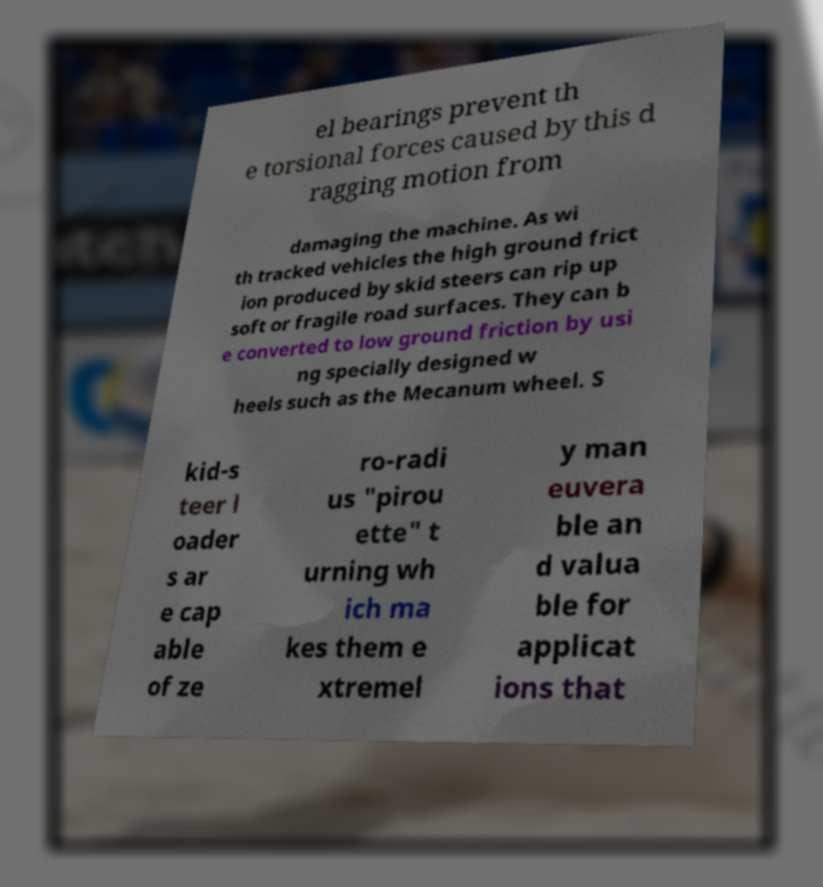For documentation purposes, I need the text within this image transcribed. Could you provide that? el bearings prevent th e torsional forces caused by this d ragging motion from damaging the machine. As wi th tracked vehicles the high ground frict ion produced by skid steers can rip up soft or fragile road surfaces. They can b e converted to low ground friction by usi ng specially designed w heels such as the Mecanum wheel. S kid-s teer l oader s ar e cap able of ze ro-radi us "pirou ette" t urning wh ich ma kes them e xtremel y man euvera ble an d valua ble for applicat ions that 